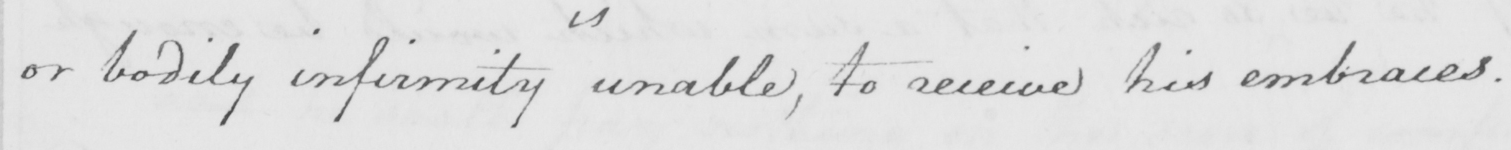What is written in this line of handwriting? or bodily infirmity unable , to receive his embraces . 